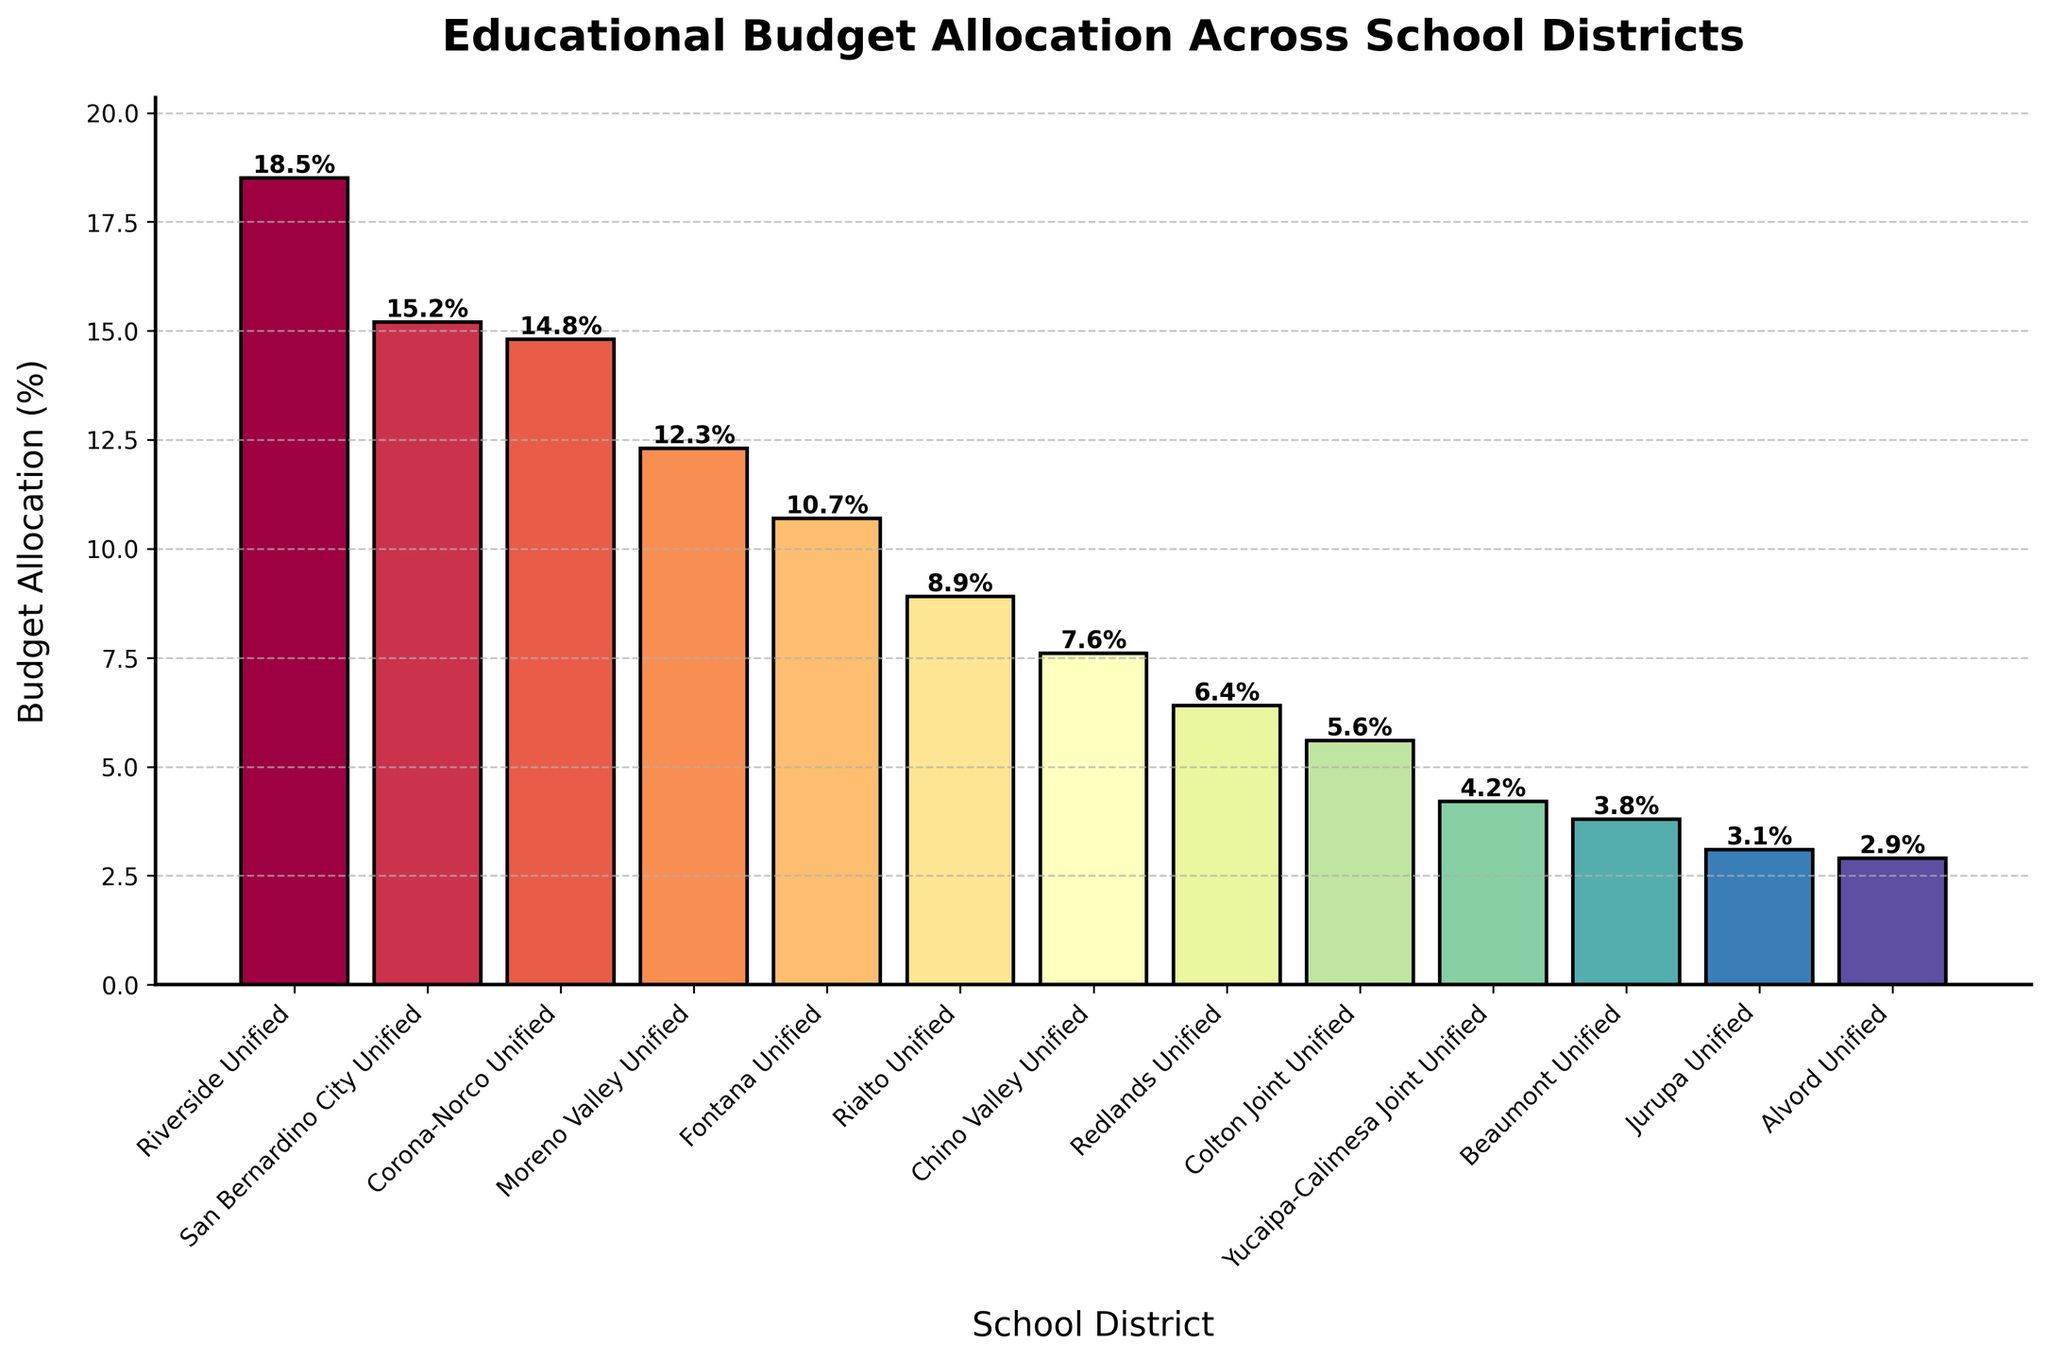Which school district has the highest budget allocation percentage? By looking at the bar representing Riverside Unified, we see it is the tallest bar in the chart, indicating it has the highest percentage.
Answer: Riverside Unified What is the combined budget allocation percentage for Moreno Valley Unified and Fontana Unified? The bars for Moreno Valley Unified and Fontana Unified show allocations of 12.3% and 10.7%, respectively. Adding them together, 12.3 + 10.7 = 23.0%.
Answer: 23.0% Which school district has the lowest budget allocation percentage, and what is it? Looking at the shortest bar, Alvord Unified, its height indicates a budget allocation of 2.9%.
Answer: Alvord Unified, 2.9% Is the budget allocation for San Bernardino City Unified greater than that for Corona-Norco Unified? Comparing the heights of the bars for San Bernardino City Unified (15.2%) and Corona-Norco Unified (14.8%), San Bernardino City Unified's bar is slightly taller.
Answer: Yes What is the difference in budget allocation percentage between Fontana Unified and Chino Valley Unified? The budget allocation percentages are 10.7% for Fontana Unified and 7.6% for Chino Valley Unified. The difference is 10.7 - 7.6 = 3.1%.
Answer: 3.1% What is the average budget allocation percentage across all school districts? To find the average, sum all the percentages: 18.5 + 15.2 + 14.8 + 12.3 + 10.7 + 8.9 + 7.6 + 6.4 + 5.6 + 4.2 + 3.8 + 3.1 + 2.9 = 114.0%. With 13 districts, the average is 114.0 / 13 ≈ 8.77%.
Answer: 8.77% Are there more school districts with a budget allocation above 10% or below 10%? By counting the bars, we see that Riverside Unified, San Bernardino City Unified, Corona-Norco Unified, Moreno Valley Unified, and Fontana Unified (5 districts) are above 10%, while the remaining 8 are below 10%.
Answer: Below 10% What school districts have a budget allocation percentage closest to the median value, and what is that median value? Ordering the percentages: 2.9, 3.1, 3.8, 4.2, 5.6, 6.4, 7.6, 8.9, 10.7, 12.3, 14.8, 15.2, 18.5. The median value, being the seventh value in an ordered list of 13, is 7.6%, corresponding to Chino Valley Unified.
Answer: Chino Valley Unified, 7.6% By what percentage is the budget allocation for Riverside Unified higher than that for Jurupa Unified? Riverside Unified has an allocation of 18.5%, and Jurupa Unified has 3.1%. The difference is 18.5 - 3.1 = 15.4%.
Answer: 15.4% Which three school districts have budget allocations close to but below the average budget allocation percentage? The average budget allocation is approximately 8.77%. On removing bars that are clearly above this figure, the school districts closest but below this value are Rialto Unified (8.9%), Chino Valley Unified (7.6%), and Redlands Unified (6.4%).
Answer: Redlands Unified, Chino Valley Unified, Rialto Unified 